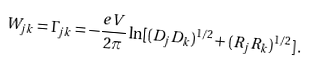Convert formula to latex. <formula><loc_0><loc_0><loc_500><loc_500>W _ { j k } = \Gamma _ { j k } = - \frac { e V } { 2 \pi } \ln [ ( D _ { j } D _ { k } ) ^ { 1 / 2 } + ( R _ { j } R _ { k } ) ^ { 1 / 2 } ] \, .</formula> 